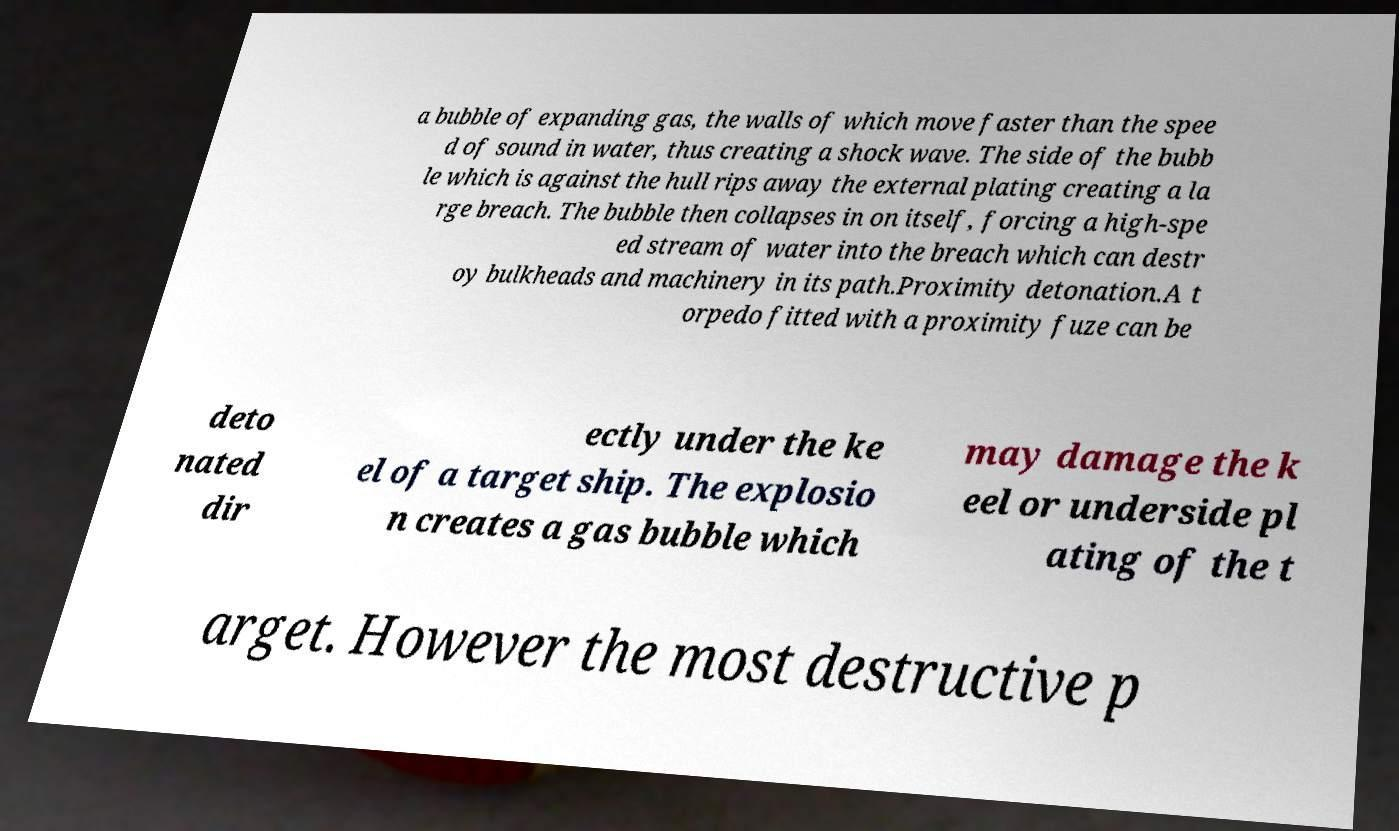There's text embedded in this image that I need extracted. Can you transcribe it verbatim? a bubble of expanding gas, the walls of which move faster than the spee d of sound in water, thus creating a shock wave. The side of the bubb le which is against the hull rips away the external plating creating a la rge breach. The bubble then collapses in on itself, forcing a high-spe ed stream of water into the breach which can destr oy bulkheads and machinery in its path.Proximity detonation.A t orpedo fitted with a proximity fuze can be deto nated dir ectly under the ke el of a target ship. The explosio n creates a gas bubble which may damage the k eel or underside pl ating of the t arget. However the most destructive p 